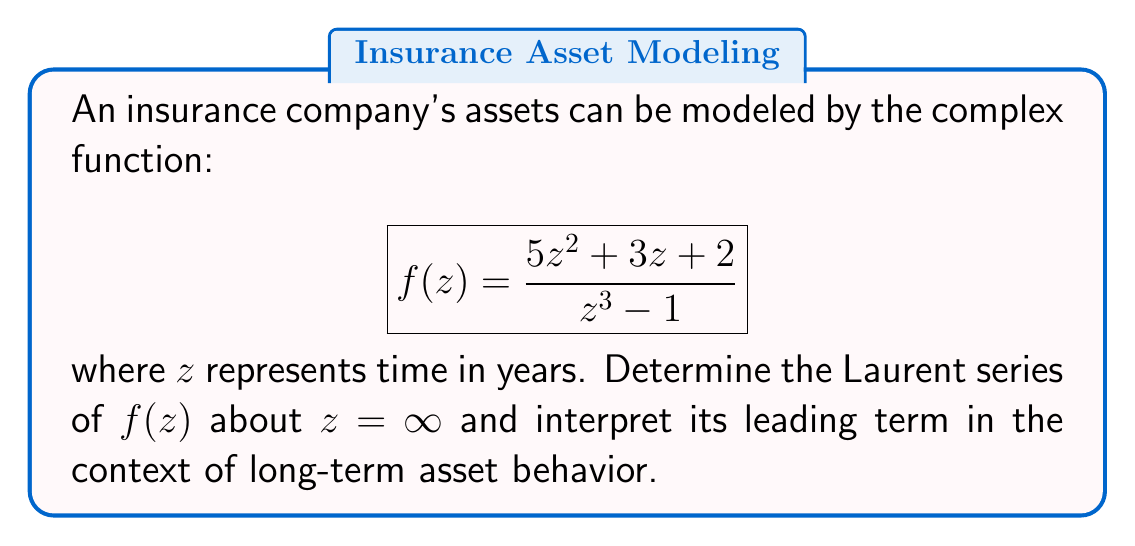Teach me how to tackle this problem. To find the Laurent series about $z = \infty$, we need to expand $f(z)$ in descending powers of $z$:

1) First, factor the denominator:
   $$z^3 - 1 = (z - 1)(z^2 + z + 1)$$

2) Divide both numerator and denominator by $z^3$:
   $$f(z) = \frac{5z^2 + 3z + 2}{z^3 - 1} = \frac{5/z + 3/z^2 + 2/z^3}{1 - 1/z^3}$$

3) Use the geometric series expansion for $\frac{1}{1-x}$ where $x = 1/z^3$:
   $$\frac{1}{1-1/z^3} = 1 + \frac{1}{z^3} + \frac{1}{z^6} + \frac{1}{z^9} + ...$$

4) Multiply this by the numerator:
   $$f(z) = (5/z + 3/z^2 + 2/z^3)(1 + \frac{1}{z^3} + \frac{1}{z^6} + ...)$$

5) Expand and collect terms:
   $$f(z) = 5/z + 3/z^2 + 2/z^3 + 5/z^4 + 3/z^5 + 2/z^6 + ...$$

This is the Laurent series of $f(z)$ about $z = \infty$.

Interpretation: The leading term $5/z$ represents the dominant long-term behavior. As $z$ (time) increases, the assets asymptotically approach zero, but at a rate proportional to $1/z$. This suggests a gradual decline in assets over time, which could indicate a need for the insurance company to adjust its strategies to maintain long-term financial stability.
Answer: $f(z) = 5/z + 3/z^2 + 2/z^3 + 5/z^4 + 3/z^5 + 2/z^6 + ...$, with $5/z$ indicating asymptotic decline in assets. 